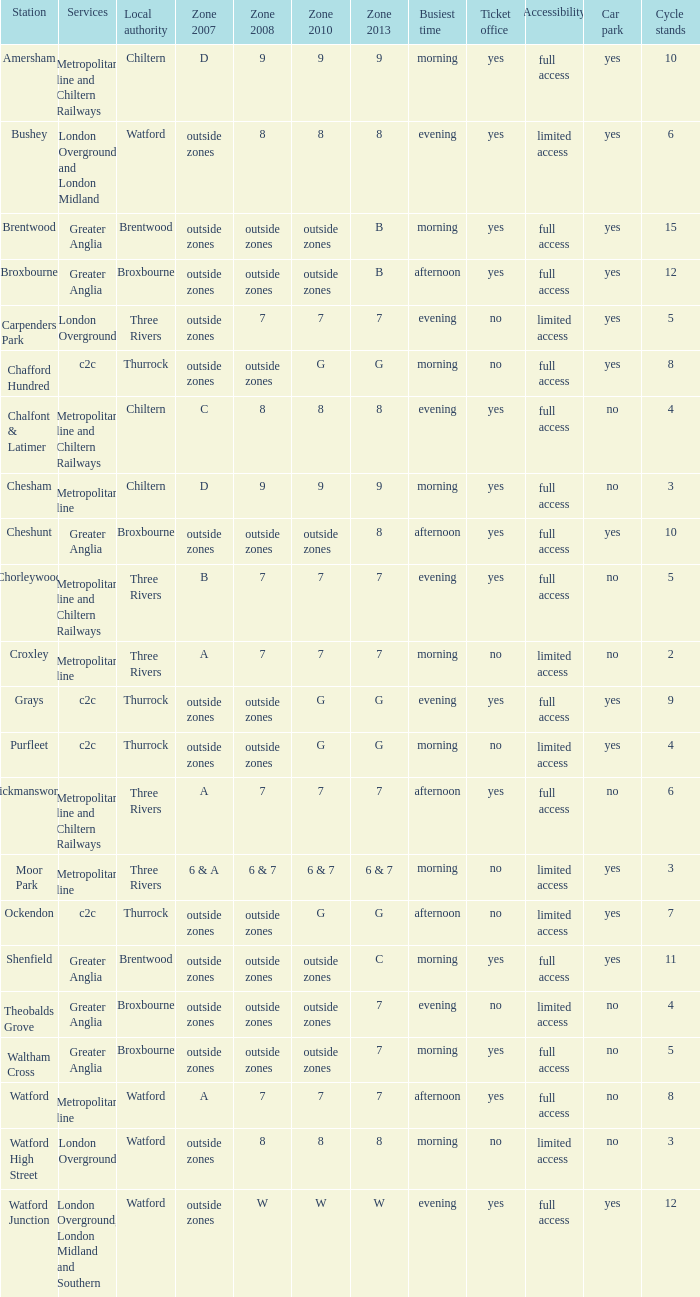Could you help me parse every detail presented in this table? {'header': ['Station', 'Services', 'Local authority', 'Zone 2007', 'Zone 2008', 'Zone 2010', 'Zone 2013', 'Busiest time', 'Ticket office', 'Accessibility', 'Car park', 'Cycle stands'], 'rows': [['Amersham', 'Metropolitan line and Chiltern Railways', 'Chiltern', 'D', '9', '9', '9', 'morning', 'yes', 'full access', 'yes', '10'], ['Bushey', 'London Overground and London Midland', 'Watford', 'outside zones', '8', '8', '8', 'evening', 'yes', 'limited access', 'yes', '6'], ['Brentwood', 'Greater Anglia', 'Brentwood', 'outside zones', 'outside zones', 'outside zones', 'B', 'morning', 'yes', 'full access', 'yes', '15'], ['Broxbourne', 'Greater Anglia', 'Broxbourne', 'outside zones', 'outside zones', 'outside zones', 'B', 'afternoon', 'yes', 'full access', 'yes', '12'], ['Carpenders Park', 'London Overground', 'Three Rivers', 'outside zones', '7', '7', '7', 'evening', 'no', 'limited access', 'yes', '5'], ['Chafford Hundred', 'c2c', 'Thurrock', 'outside zones', 'outside zones', 'G', 'G', 'morning', 'no', 'full access', 'yes', '8'], ['Chalfont & Latimer', 'Metropolitan line and Chiltern Railways', 'Chiltern', 'C', '8', '8', '8', 'evening', 'yes', 'full access', 'no', '4'], ['Chesham', 'Metropolitan line', 'Chiltern', 'D', '9', '9', '9', 'morning', 'yes', 'full access', 'no', '3'], ['Cheshunt', 'Greater Anglia', 'Broxbourne', 'outside zones', 'outside zones', 'outside zones', '8', 'afternoon', 'yes', 'full access', 'yes', '10'], ['Chorleywood', 'Metropolitan line and Chiltern Railways', 'Three Rivers', 'B', '7', '7', '7', 'evening', 'yes', 'full access', 'no', '5'], ['Croxley', 'Metropolitan line', 'Three Rivers', 'A', '7', '7', '7', 'morning', 'no', 'limited access', 'no', '2'], ['Grays', 'c2c', 'Thurrock', 'outside zones', 'outside zones', 'G', 'G', 'evening', 'yes', 'full access', 'yes', '9'], ['Purfleet', 'c2c', 'Thurrock', 'outside zones', 'outside zones', 'G', 'G', 'morning', 'no', 'limited access', 'yes', '4'], ['Rickmansworth', 'Metropolitan line and Chiltern Railways', 'Three Rivers', 'A', '7', '7', '7', 'afternoon', 'yes', 'full access', 'no', '6'], ['Moor Park', 'Metropolitan line', 'Three Rivers', '6 & A', '6 & 7', '6 & 7', '6 & 7', 'morning', 'no', 'limited access', 'yes', '3'], ['Ockendon', 'c2c', 'Thurrock', 'outside zones', 'outside zones', 'G', 'G', 'afternoon', 'no', 'limited access', 'yes', '7'], ['Shenfield', 'Greater Anglia', 'Brentwood', 'outside zones', 'outside zones', 'outside zones', 'C', 'morning', 'yes', 'full access', 'yes', '11'], ['Theobalds Grove', 'Greater Anglia', 'Broxbourne', 'outside zones', 'outside zones', 'outside zones', '7', 'evening', 'no', 'limited access', 'no', '4'], ['Waltham Cross', 'Greater Anglia', 'Broxbourne', 'outside zones', 'outside zones', 'outside zones', '7', 'morning', 'yes', 'full access', 'no', '5'], ['Watford', 'Metropolitan line', 'Watford', 'A', '7', '7', '7', 'afternoon', 'yes', 'full access', 'no', '8'], ['Watford High Street', 'London Overground', 'Watford', 'outside zones', '8', '8', '8', 'morning', 'no', 'limited access', 'no', '3'], ['Watford Junction', 'London Overground, London Midland and Southern', 'Watford', 'outside zones', 'W', 'W', 'W', 'evening', 'yes', 'full access', 'yes', '12']]} Which Station has a Zone 2008 of 8, and a Zone 2007 of outside zones, and Services of london overground? Watford High Street. 